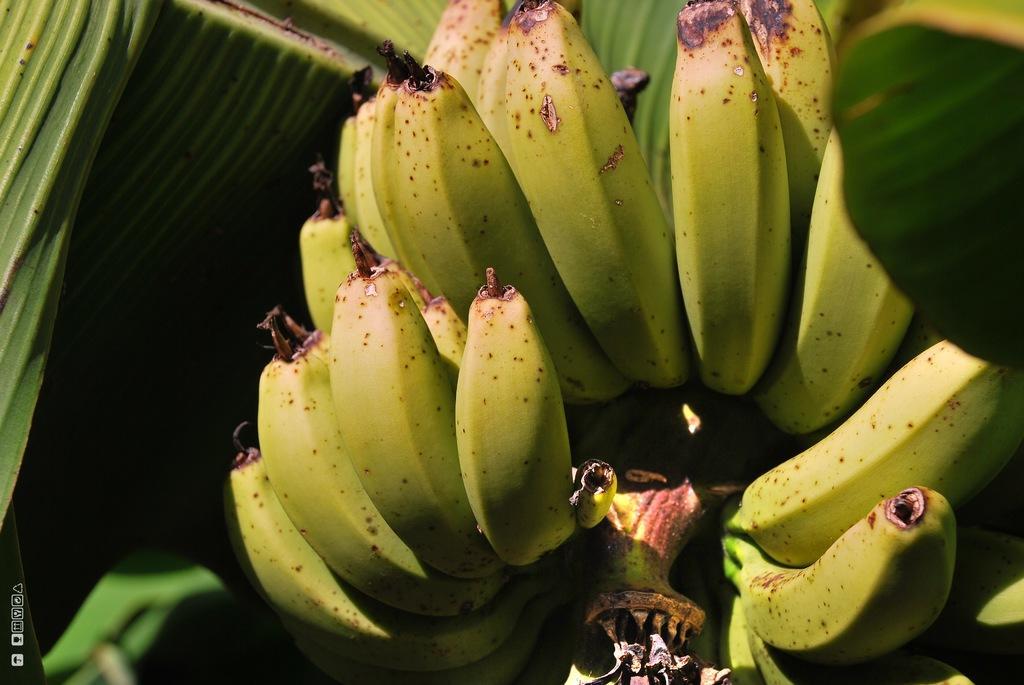Can you describe this image briefly? As we can see in the image there are leaves and bananas. 